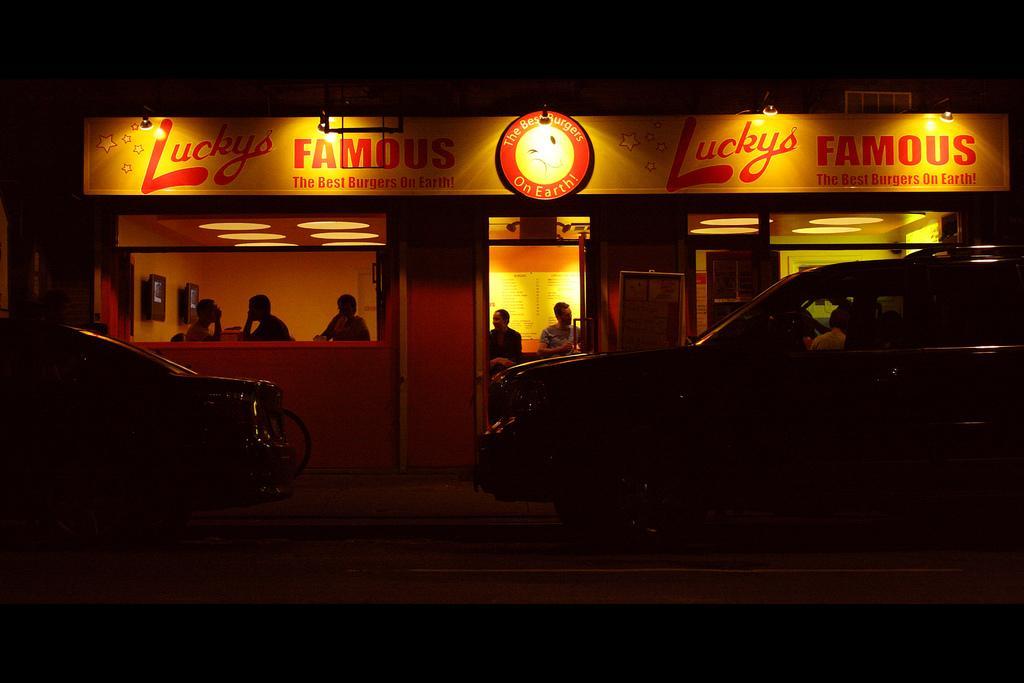Describe this image in one or two sentences. In this picture, we see many people sitting in the room and behind these people, we see a white board with some text written on it. Above that, we see a hoarding board on which "Luckys" is written on it and beside that, we see vehicles moving on road and this picture is taken in dark. 